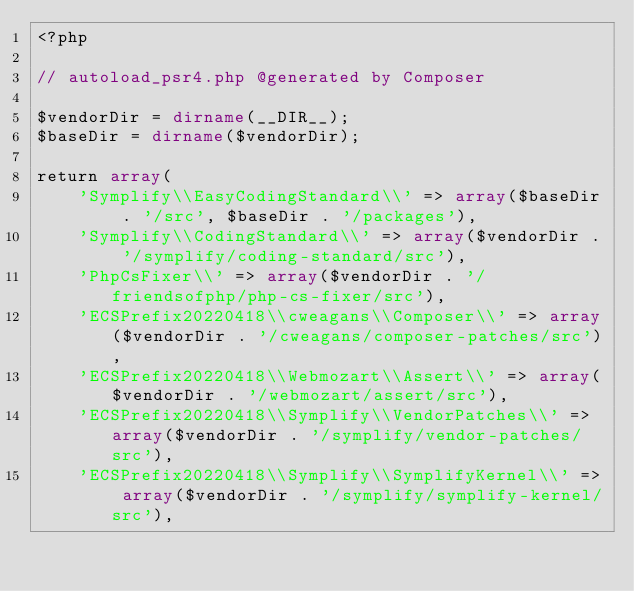<code> <loc_0><loc_0><loc_500><loc_500><_PHP_><?php

// autoload_psr4.php @generated by Composer

$vendorDir = dirname(__DIR__);
$baseDir = dirname($vendorDir);

return array(
    'Symplify\\EasyCodingStandard\\' => array($baseDir . '/src', $baseDir . '/packages'),
    'Symplify\\CodingStandard\\' => array($vendorDir . '/symplify/coding-standard/src'),
    'PhpCsFixer\\' => array($vendorDir . '/friendsofphp/php-cs-fixer/src'),
    'ECSPrefix20220418\\cweagans\\Composer\\' => array($vendorDir . '/cweagans/composer-patches/src'),
    'ECSPrefix20220418\\Webmozart\\Assert\\' => array($vendorDir . '/webmozart/assert/src'),
    'ECSPrefix20220418\\Symplify\\VendorPatches\\' => array($vendorDir . '/symplify/vendor-patches/src'),
    'ECSPrefix20220418\\Symplify\\SymplifyKernel\\' => array($vendorDir . '/symplify/symplify-kernel/src'),</code> 